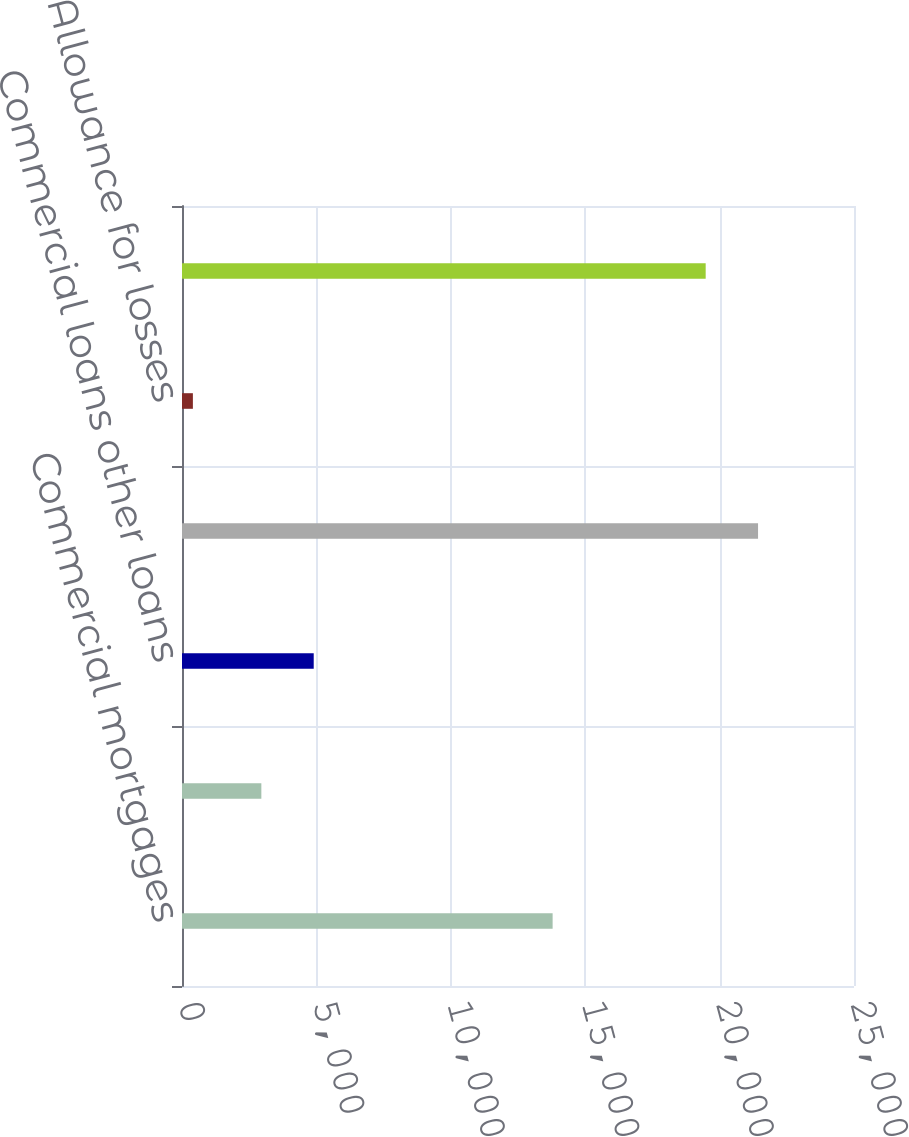Convert chart to OTSL. <chart><loc_0><loc_0><loc_500><loc_500><bar_chart><fcel>Commercial mortgages<fcel>Life insurance policy loans<fcel>Commercial loans other loans<fcel>Total mortgage and other loans<fcel>Allowance for losses<fcel>Mortgage and other loans<nl><fcel>13788<fcel>2952<fcel>4900.2<fcel>21430.2<fcel>405<fcel>19482<nl></chart> 